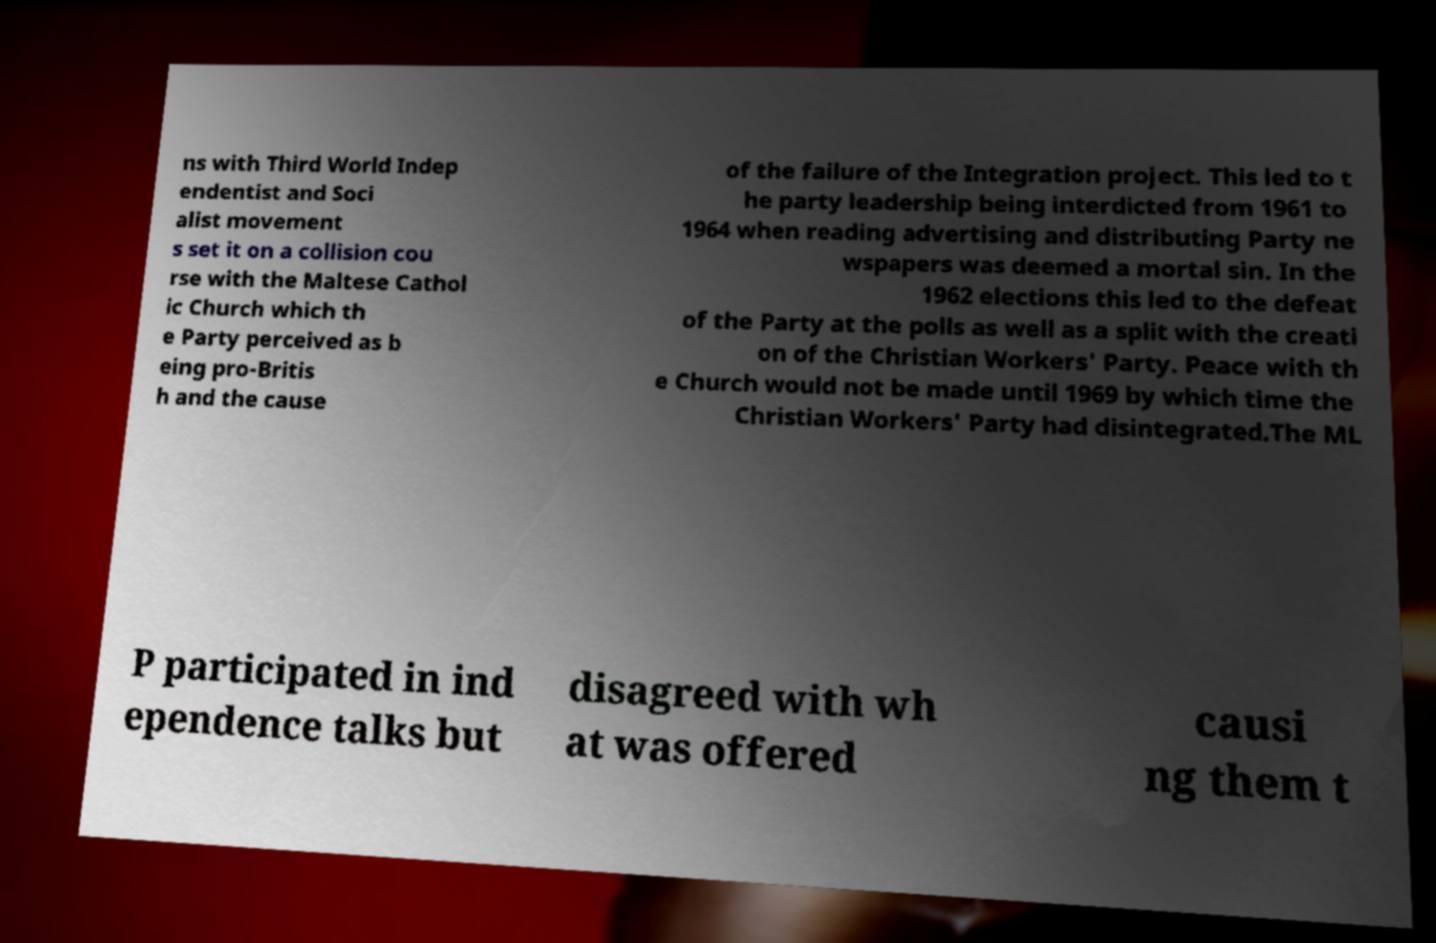Can you accurately transcribe the text from the provided image for me? ns with Third World Indep endentist and Soci alist movement s set it on a collision cou rse with the Maltese Cathol ic Church which th e Party perceived as b eing pro-Britis h and the cause of the failure of the Integration project. This led to t he party leadership being interdicted from 1961 to 1964 when reading advertising and distributing Party ne wspapers was deemed a mortal sin. In the 1962 elections this led to the defeat of the Party at the polls as well as a split with the creati on of the Christian Workers' Party. Peace with th e Church would not be made until 1969 by which time the Christian Workers' Party had disintegrated.The ML P participated in ind ependence talks but disagreed with wh at was offered causi ng them t 